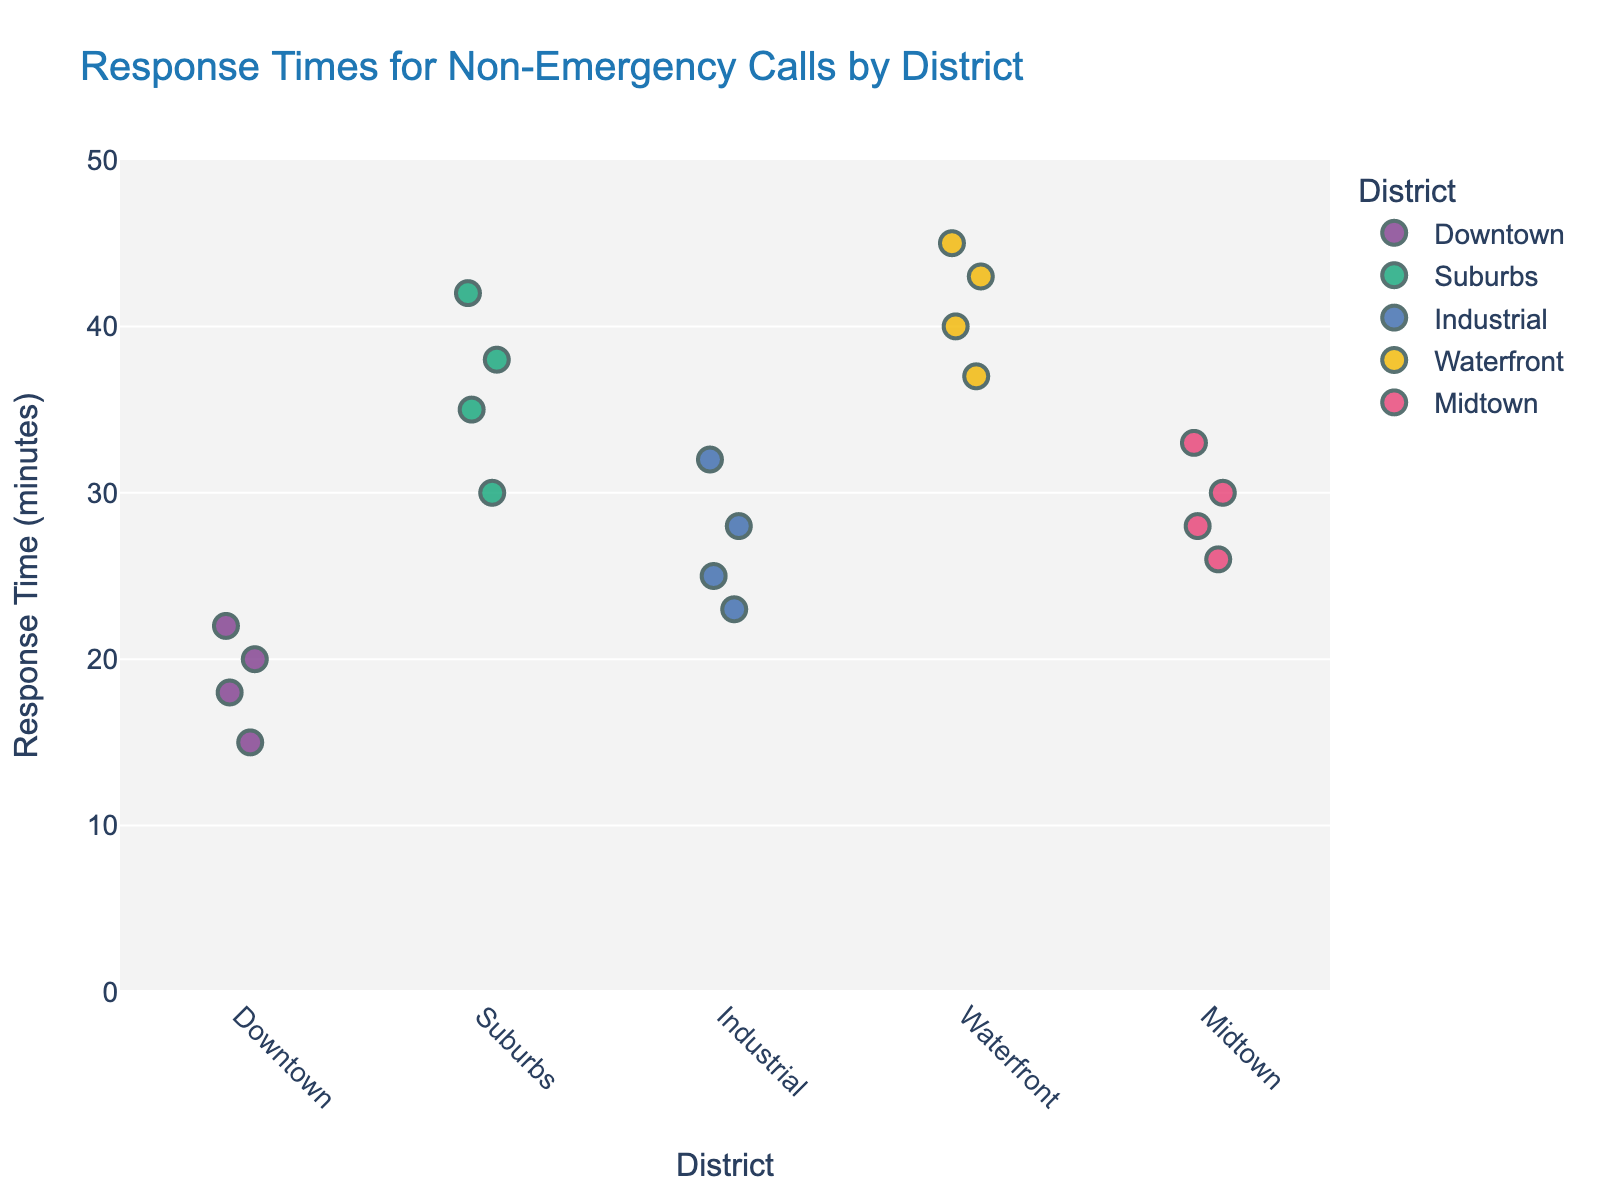what is the title of the plot? The title of the plot is displayed at the top and usually summarizes what the data visualization is about, helping viewers quickly understand the context. In this case, the title is "Response Times for Non-Emergency Calls by District".
Answer: Response Times for Non-Emergency Calls by District What are the district names shown on the x-axis? The x-axis displays the categories or groups being analyzed, which in this case are the district names. The districts included are Downtown, Suburbs, Industrial, Waterfront, and Midtown.
Answer: Downtown, Suburbs, Industrial, Waterfront, and Midtown How many data points are there for the Downtown district? Each individual point in the strip plot represents a response time for that particular district. By counting the points under the Downtown label, we find there are four data points.
Answer: 4 Which district has the highest overall response time? To determine this, we look at the highest points on the y-axis for each district. The Waterfront district has the highest overall response time, which reaches up to 45 minutes.
Answer: Waterfront What is the average response time for the Suburbs district? To find the average response time, we sum the response times for the Suburbs district and divide by the number of data points. The response times are 35, 42, 38, and 30, giving a sum of 145. Dividing by the 4 data points gives an average response time of 36.25 minutes.
Answer: 36.25 Is Midtown's highest response time higher than Industrial's lowest response time? We identify the highest response time for Midtown, which is 33 minutes, and the lowest response time for Industrial, which is 23 minutes. Comparing these, 33 minutes is indeed higher than 23 minutes.
Answer: Yes Which district shows the most variability in response times? Variability can be gauged visually by the spread of points along the y-axis for each district. The Waterfront district has points spread from 37 to 45, indicating high variability.
Answer: Waterfront What is the difference between the highest and lowest response times in the Industrial district? The highest point in the Industrial district is at 32 minutes and the lowest point is at 23 minutes. The difference between these two values is 32 - 23 = 9 minutes.
Answer: 9 Compare the median response times of Downtown and Midtown districts. Which one is higher? To find the median, we list the response times in ascending order and find the middle value. For Downtown (15, 18, 20, 22), the median is (18+20)/2 = 19. For Midtown (26, 28, 30, 33), the median is (28+30)/2 = 29. Midtown's median response time is higher.
Answer: Midtown 